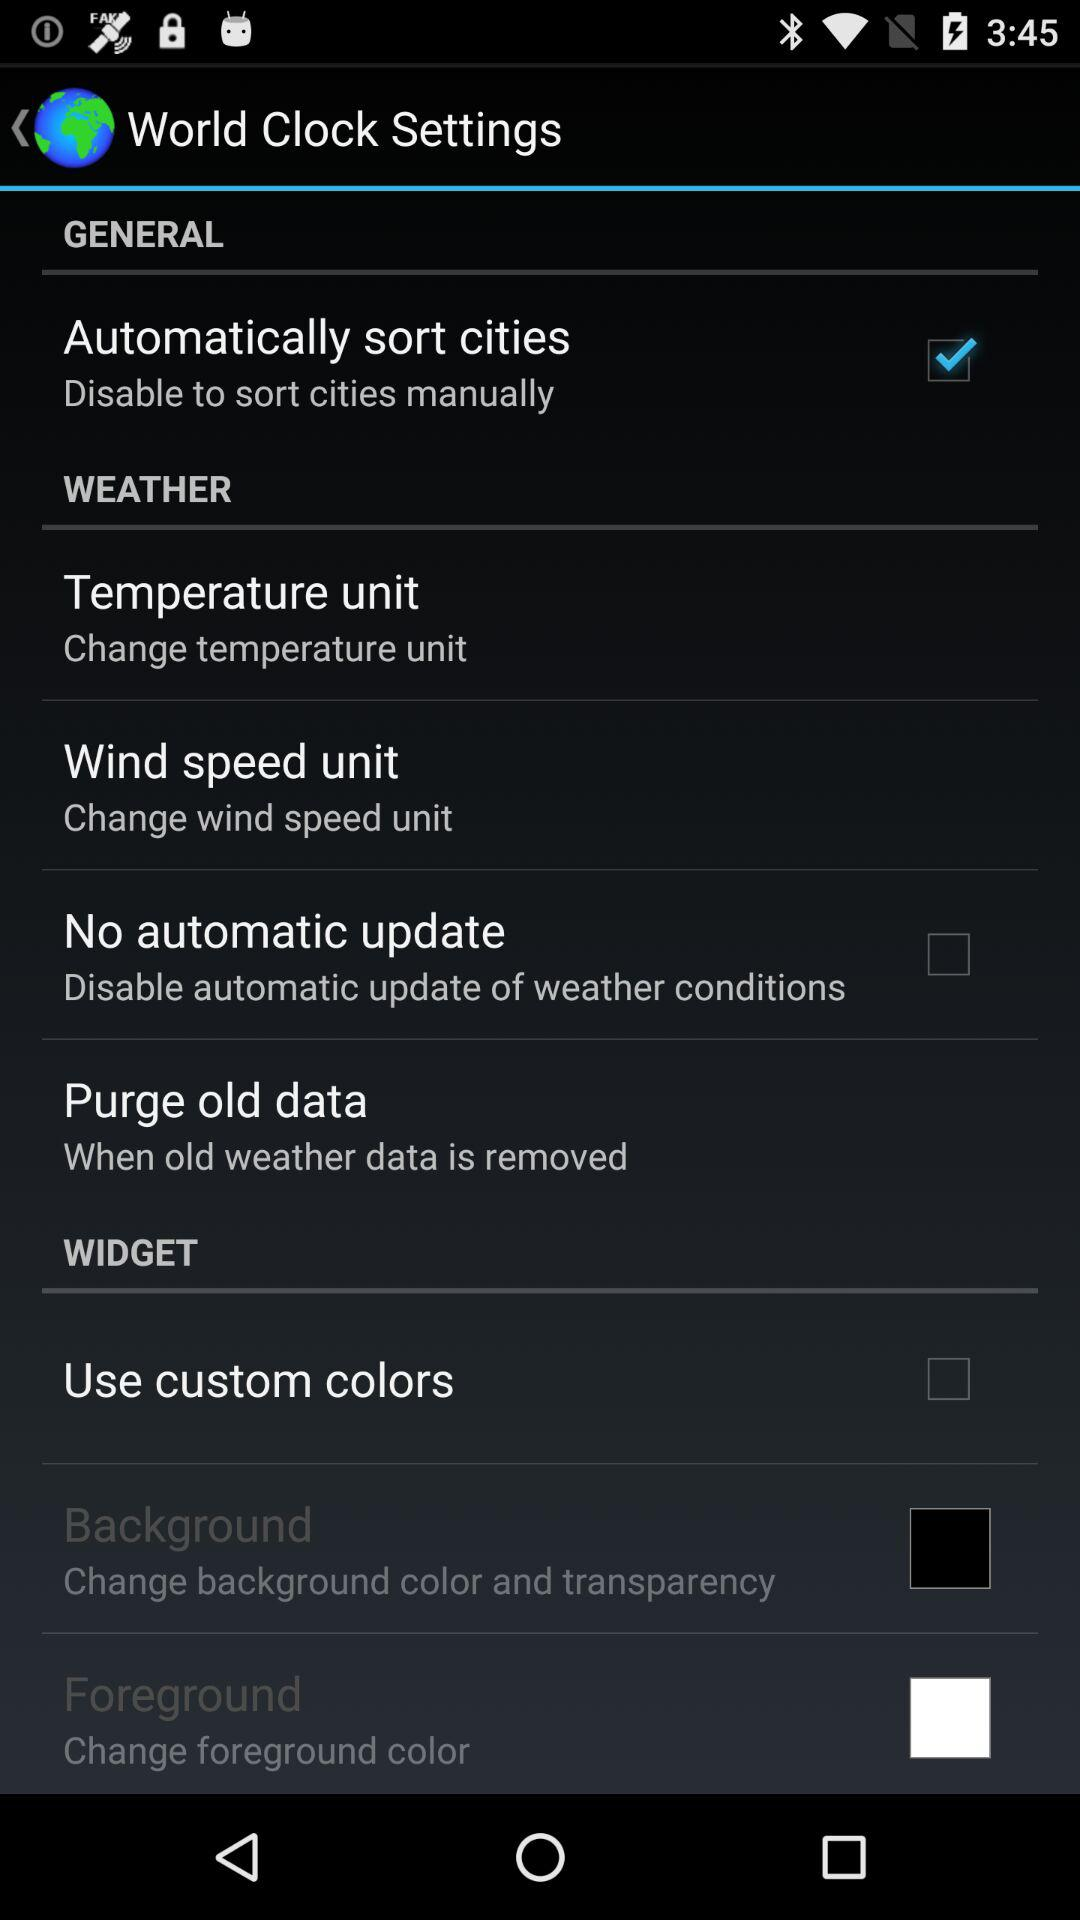Which setting has been selected? The setting "Automatically sort cities" has been selected. 